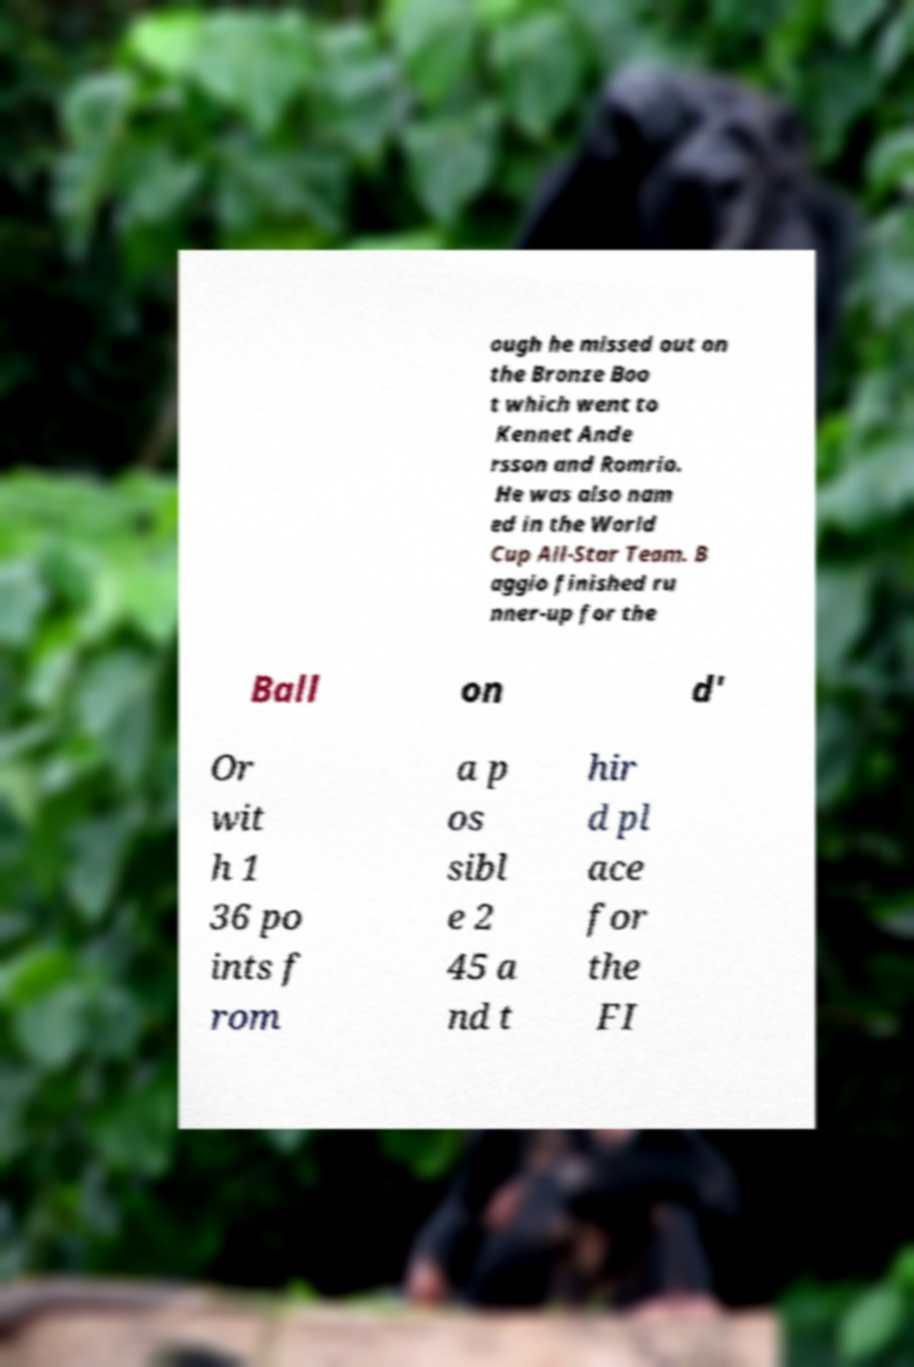For documentation purposes, I need the text within this image transcribed. Could you provide that? ough he missed out on the Bronze Boo t which went to Kennet Ande rsson and Romrio. He was also nam ed in the World Cup All-Star Team. B aggio finished ru nner-up for the Ball on d' Or wit h 1 36 po ints f rom a p os sibl e 2 45 a nd t hir d pl ace for the FI 